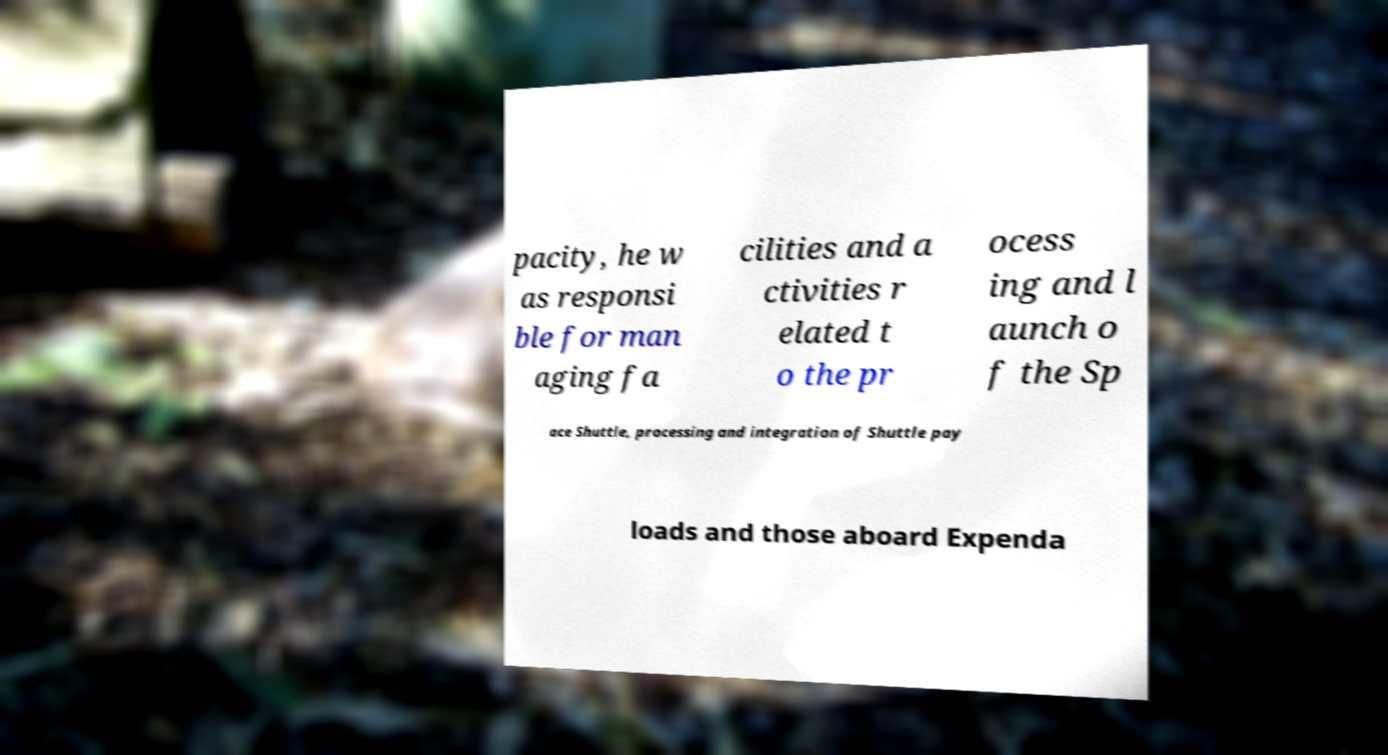Can you accurately transcribe the text from the provided image for me? pacity, he w as responsi ble for man aging fa cilities and a ctivities r elated t o the pr ocess ing and l aunch o f the Sp ace Shuttle, processing and integration of Shuttle pay loads and those aboard Expenda 